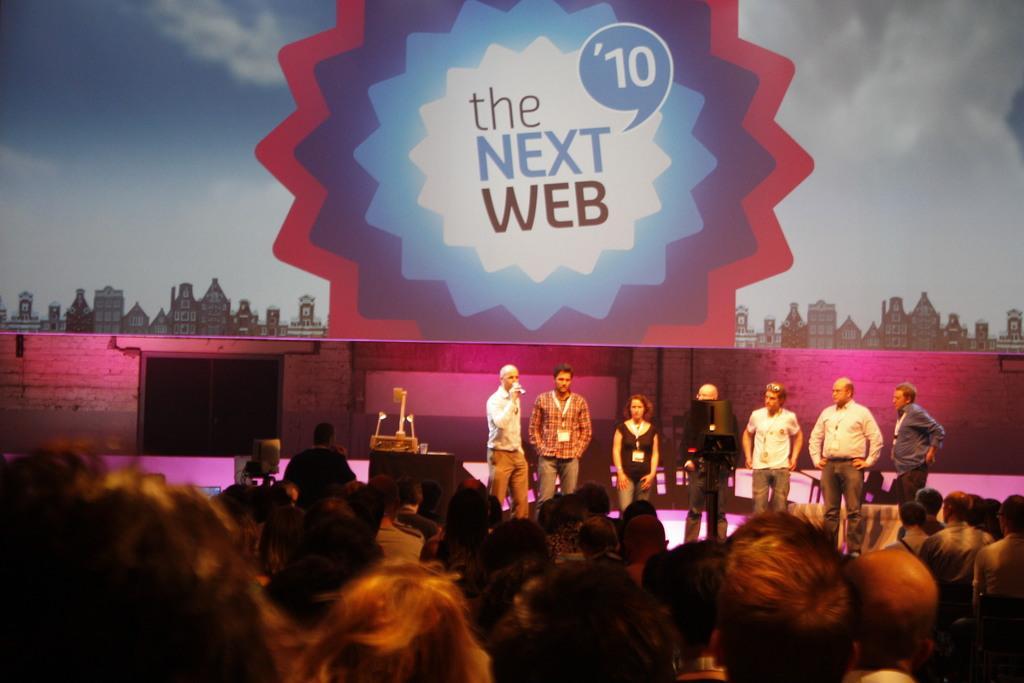Describe this image in one or two sentences. In this picture we can see a group of people and in the background we can see a banner. 